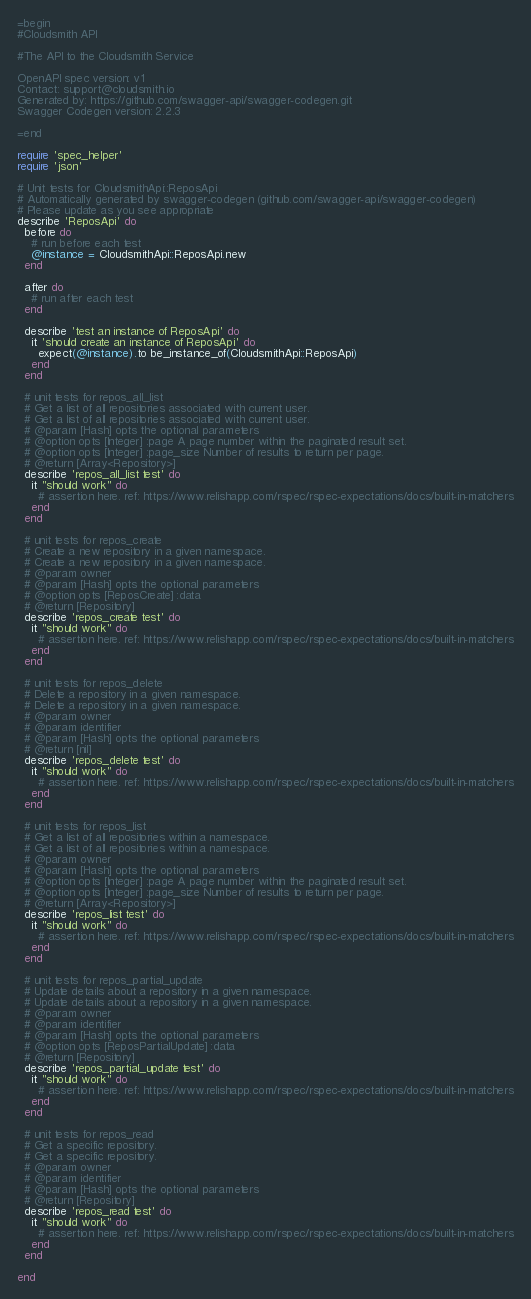<code> <loc_0><loc_0><loc_500><loc_500><_Ruby_>=begin
#Cloudsmith API

#The API to the Cloudsmith Service

OpenAPI spec version: v1
Contact: support@cloudsmith.io
Generated by: https://github.com/swagger-api/swagger-codegen.git
Swagger Codegen version: 2.2.3

=end

require 'spec_helper'
require 'json'

# Unit tests for CloudsmithApi::ReposApi
# Automatically generated by swagger-codegen (github.com/swagger-api/swagger-codegen)
# Please update as you see appropriate
describe 'ReposApi' do
  before do
    # run before each test
    @instance = CloudsmithApi::ReposApi.new
  end

  after do
    # run after each test
  end

  describe 'test an instance of ReposApi' do
    it 'should create an instance of ReposApi' do
      expect(@instance).to be_instance_of(CloudsmithApi::ReposApi)
    end
  end

  # unit tests for repos_all_list
  # Get a list of all repositories associated with current user.
  # Get a list of all repositories associated with current user.
  # @param [Hash] opts the optional parameters
  # @option opts [Integer] :page A page number within the paginated result set.
  # @option opts [Integer] :page_size Number of results to return per page.
  # @return [Array<Repository>]
  describe 'repos_all_list test' do
    it "should work" do
      # assertion here. ref: https://www.relishapp.com/rspec/rspec-expectations/docs/built-in-matchers
    end
  end

  # unit tests for repos_create
  # Create a new repository in a given namespace.
  # Create a new repository in a given namespace.
  # @param owner 
  # @param [Hash] opts the optional parameters
  # @option opts [ReposCreate] :data 
  # @return [Repository]
  describe 'repos_create test' do
    it "should work" do
      # assertion here. ref: https://www.relishapp.com/rspec/rspec-expectations/docs/built-in-matchers
    end
  end

  # unit tests for repos_delete
  # Delete a repository in a given namespace.
  # Delete a repository in a given namespace.
  # @param owner 
  # @param identifier 
  # @param [Hash] opts the optional parameters
  # @return [nil]
  describe 'repos_delete test' do
    it "should work" do
      # assertion here. ref: https://www.relishapp.com/rspec/rspec-expectations/docs/built-in-matchers
    end
  end

  # unit tests for repos_list
  # Get a list of all repositories within a namespace.
  # Get a list of all repositories within a namespace.
  # @param owner 
  # @param [Hash] opts the optional parameters
  # @option opts [Integer] :page A page number within the paginated result set.
  # @option opts [Integer] :page_size Number of results to return per page.
  # @return [Array<Repository>]
  describe 'repos_list test' do
    it "should work" do
      # assertion here. ref: https://www.relishapp.com/rspec/rspec-expectations/docs/built-in-matchers
    end
  end

  # unit tests for repos_partial_update
  # Update details about a repository in a given namespace.
  # Update details about a repository in a given namespace.
  # @param owner 
  # @param identifier 
  # @param [Hash] opts the optional parameters
  # @option opts [ReposPartialUpdate] :data 
  # @return [Repository]
  describe 'repos_partial_update test' do
    it "should work" do
      # assertion here. ref: https://www.relishapp.com/rspec/rspec-expectations/docs/built-in-matchers
    end
  end

  # unit tests for repos_read
  # Get a specific repository.
  # Get a specific repository.
  # @param owner 
  # @param identifier 
  # @param [Hash] opts the optional parameters
  # @return [Repository]
  describe 'repos_read test' do
    it "should work" do
      # assertion here. ref: https://www.relishapp.com/rspec/rspec-expectations/docs/built-in-matchers
    end
  end

end
</code> 